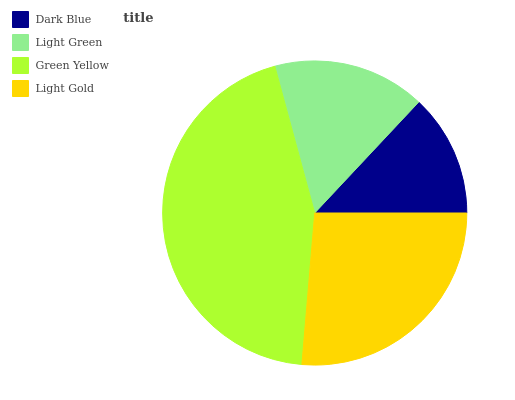Is Dark Blue the minimum?
Answer yes or no. Yes. Is Green Yellow the maximum?
Answer yes or no. Yes. Is Light Green the minimum?
Answer yes or no. No. Is Light Green the maximum?
Answer yes or no. No. Is Light Green greater than Dark Blue?
Answer yes or no. Yes. Is Dark Blue less than Light Green?
Answer yes or no. Yes. Is Dark Blue greater than Light Green?
Answer yes or no. No. Is Light Green less than Dark Blue?
Answer yes or no. No. Is Light Gold the high median?
Answer yes or no. Yes. Is Light Green the low median?
Answer yes or no. Yes. Is Dark Blue the high median?
Answer yes or no. No. Is Green Yellow the low median?
Answer yes or no. No. 